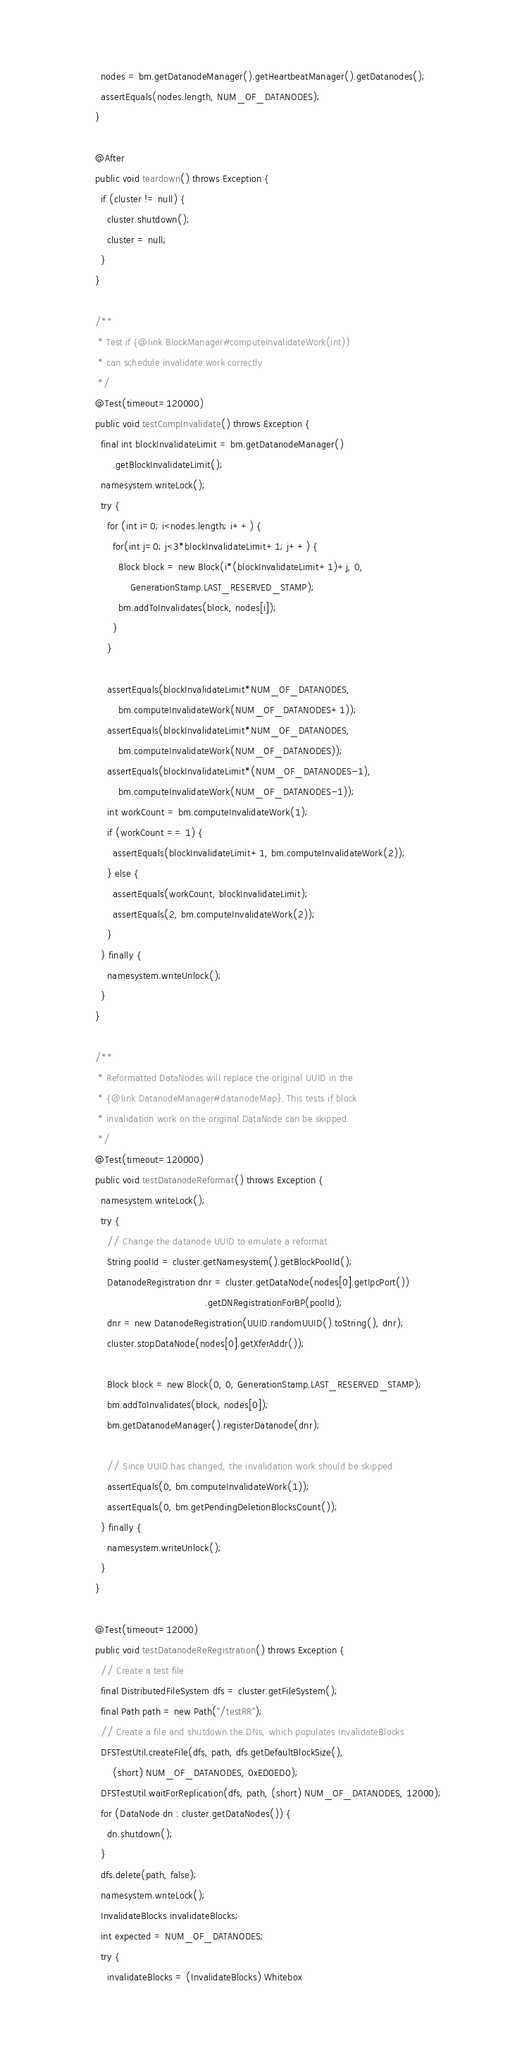<code> <loc_0><loc_0><loc_500><loc_500><_Java_>    nodes = bm.getDatanodeManager().getHeartbeatManager().getDatanodes();
    assertEquals(nodes.length, NUM_OF_DATANODES);
  }

  @After
  public void teardown() throws Exception {
    if (cluster != null) {
      cluster.shutdown();
      cluster = null;
    }
  }

  /**
   * Test if {@link BlockManager#computeInvalidateWork(int)}
   * can schedule invalidate work correctly 
   */
  @Test(timeout=120000)
  public void testCompInvalidate() throws Exception {
    final int blockInvalidateLimit = bm.getDatanodeManager()
        .getBlockInvalidateLimit();
    namesystem.writeLock();
    try {
      for (int i=0; i<nodes.length; i++) {
        for(int j=0; j<3*blockInvalidateLimit+1; j++) {
          Block block = new Block(i*(blockInvalidateLimit+1)+j, 0,
              GenerationStamp.LAST_RESERVED_STAMP);
          bm.addToInvalidates(block, nodes[i]);
        }
      }
      
      assertEquals(blockInvalidateLimit*NUM_OF_DATANODES,
          bm.computeInvalidateWork(NUM_OF_DATANODES+1));
      assertEquals(blockInvalidateLimit*NUM_OF_DATANODES,
          bm.computeInvalidateWork(NUM_OF_DATANODES));
      assertEquals(blockInvalidateLimit*(NUM_OF_DATANODES-1),
          bm.computeInvalidateWork(NUM_OF_DATANODES-1));
      int workCount = bm.computeInvalidateWork(1);
      if (workCount == 1) {
        assertEquals(blockInvalidateLimit+1, bm.computeInvalidateWork(2));
      } else {
        assertEquals(workCount, blockInvalidateLimit);
        assertEquals(2, bm.computeInvalidateWork(2));
      }
    } finally {
      namesystem.writeUnlock();
    }
  }

  /**
   * Reformatted DataNodes will replace the original UUID in the
   * {@link DatanodeManager#datanodeMap}. This tests if block
   * invalidation work on the original DataNode can be skipped.
   */
  @Test(timeout=120000)
  public void testDatanodeReformat() throws Exception {
    namesystem.writeLock();
    try {
      // Change the datanode UUID to emulate a reformat
      String poolId = cluster.getNamesystem().getBlockPoolId();
      DatanodeRegistration dnr = cluster.getDataNode(nodes[0].getIpcPort())
                                        .getDNRegistrationForBP(poolId);
      dnr = new DatanodeRegistration(UUID.randomUUID().toString(), dnr);
      cluster.stopDataNode(nodes[0].getXferAddr());

      Block block = new Block(0, 0, GenerationStamp.LAST_RESERVED_STAMP);
      bm.addToInvalidates(block, nodes[0]);
      bm.getDatanodeManager().registerDatanode(dnr);

      // Since UUID has changed, the invalidation work should be skipped
      assertEquals(0, bm.computeInvalidateWork(1));
      assertEquals(0, bm.getPendingDeletionBlocksCount());
    } finally {
      namesystem.writeUnlock();
    }
  }

  @Test(timeout=12000)
  public void testDatanodeReRegistration() throws Exception {
    // Create a test file
    final DistributedFileSystem dfs = cluster.getFileSystem();
    final Path path = new Path("/testRR");
    // Create a file and shutdown the DNs, which populates InvalidateBlocks
    DFSTestUtil.createFile(dfs, path, dfs.getDefaultBlockSize(),
        (short) NUM_OF_DATANODES, 0xED0ED0);
    DFSTestUtil.waitForReplication(dfs, path, (short) NUM_OF_DATANODES, 12000);
    for (DataNode dn : cluster.getDataNodes()) {
      dn.shutdown();
    }
    dfs.delete(path, false);
    namesystem.writeLock();
    InvalidateBlocks invalidateBlocks;
    int expected = NUM_OF_DATANODES;
    try {
      invalidateBlocks = (InvalidateBlocks) Whitebox</code> 